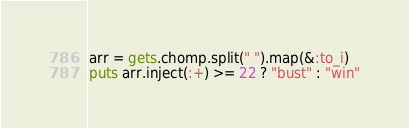Convert code to text. <code><loc_0><loc_0><loc_500><loc_500><_Ruby_>arr = gets.chomp.split(" ").map(&:to_i)
puts arr.inject(:+) >= 22 ? "bust" : "win"
</code> 